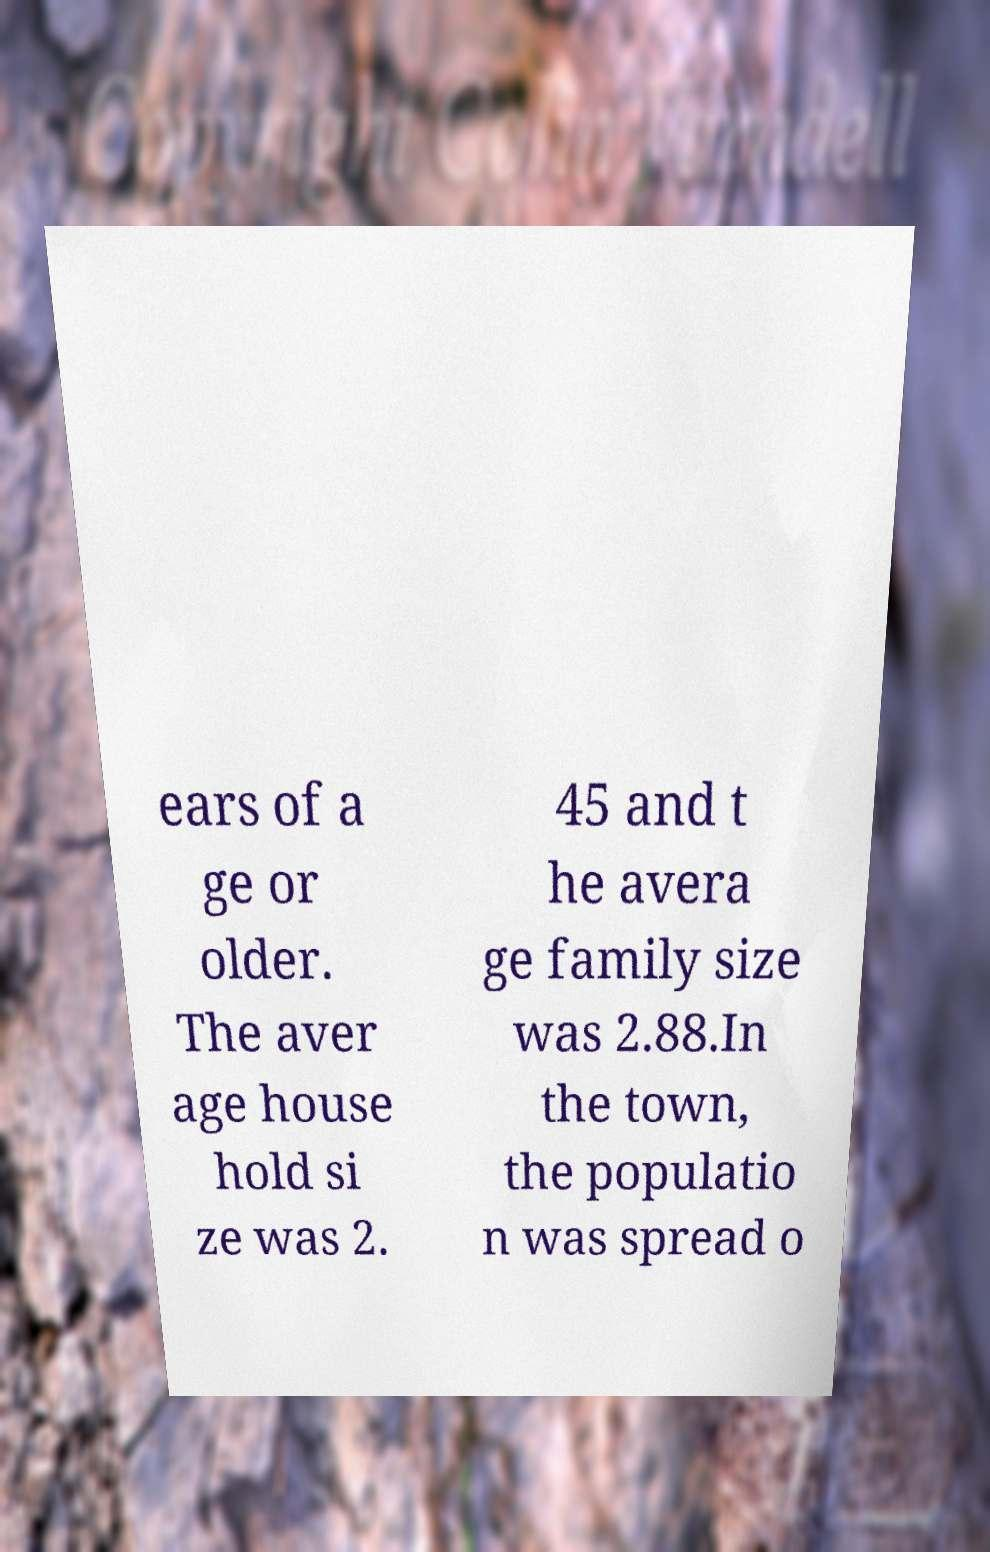What messages or text are displayed in this image? I need them in a readable, typed format. ears of a ge or older. The aver age house hold si ze was 2. 45 and t he avera ge family size was 2.88.In the town, the populatio n was spread o 